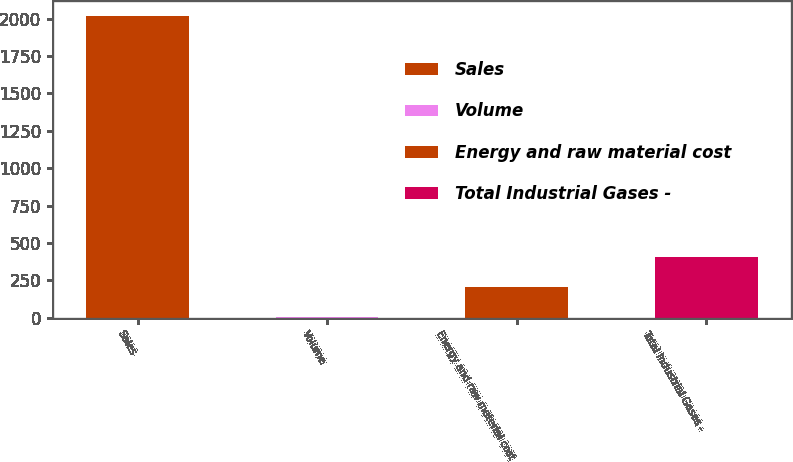<chart> <loc_0><loc_0><loc_500><loc_500><bar_chart><fcel>Sales<fcel>Volume<fcel>Energy and raw material cost<fcel>Total Industrial Gases -<nl><fcel>2017<fcel>2<fcel>203.5<fcel>405<nl></chart> 